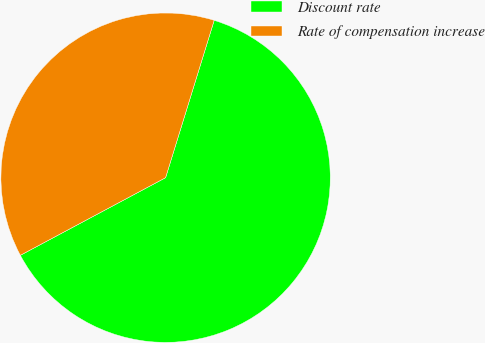Convert chart to OTSL. <chart><loc_0><loc_0><loc_500><loc_500><pie_chart><fcel>Discount rate<fcel>Rate of compensation increase<nl><fcel>62.42%<fcel>37.58%<nl></chart> 